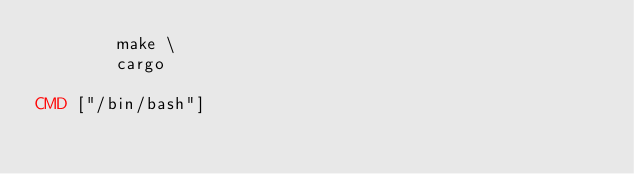<code> <loc_0><loc_0><loc_500><loc_500><_Dockerfile_>        make \
        cargo

CMD ["/bin/bash"]
</code> 